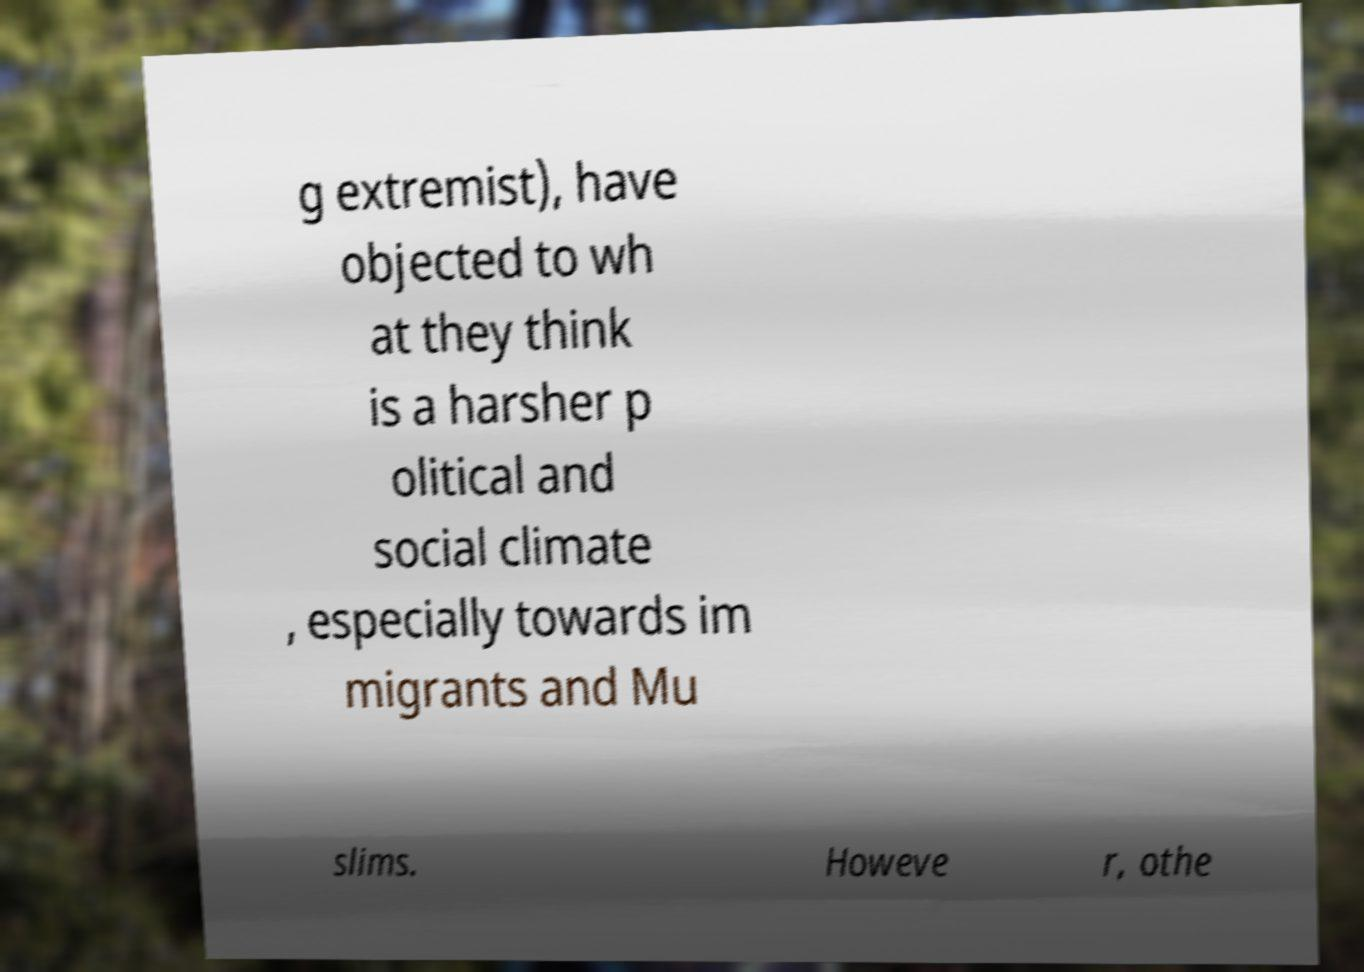Can you read and provide the text displayed in the image?This photo seems to have some interesting text. Can you extract and type it out for me? g extremist), have objected to wh at they think is a harsher p olitical and social climate , especially towards im migrants and Mu slims. Howeve r, othe 